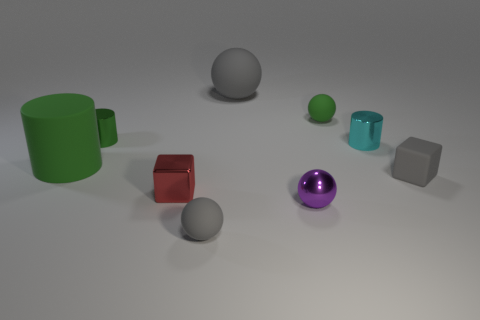How many shiny cylinders are on the right side of the tiny shiny sphere that is on the right side of the gray sphere that is behind the cyan metal cylinder? Observing the image closely, we find that directly on the right side of the tiny shiny sphere, which itself is on the right side of the gray sphere positioned behind the cyan metal cylinder, there appears to be exactly one shiny cylinder. 